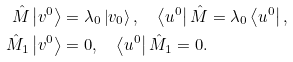<formula> <loc_0><loc_0><loc_500><loc_500>\hat { M } \left | v ^ { 0 } \right \rangle & = \lambda _ { 0 } \left | v _ { 0 } \right \rangle , \quad \left \langle u ^ { 0 } \right | \hat { M } = \lambda _ { 0 } \left \langle u ^ { 0 } \right | , \\ \hat { M } _ { 1 } \left | v ^ { 0 } \right \rangle & = 0 , \quad \left \langle u ^ { 0 } \right | \hat { M } _ { 1 } = 0 .</formula> 